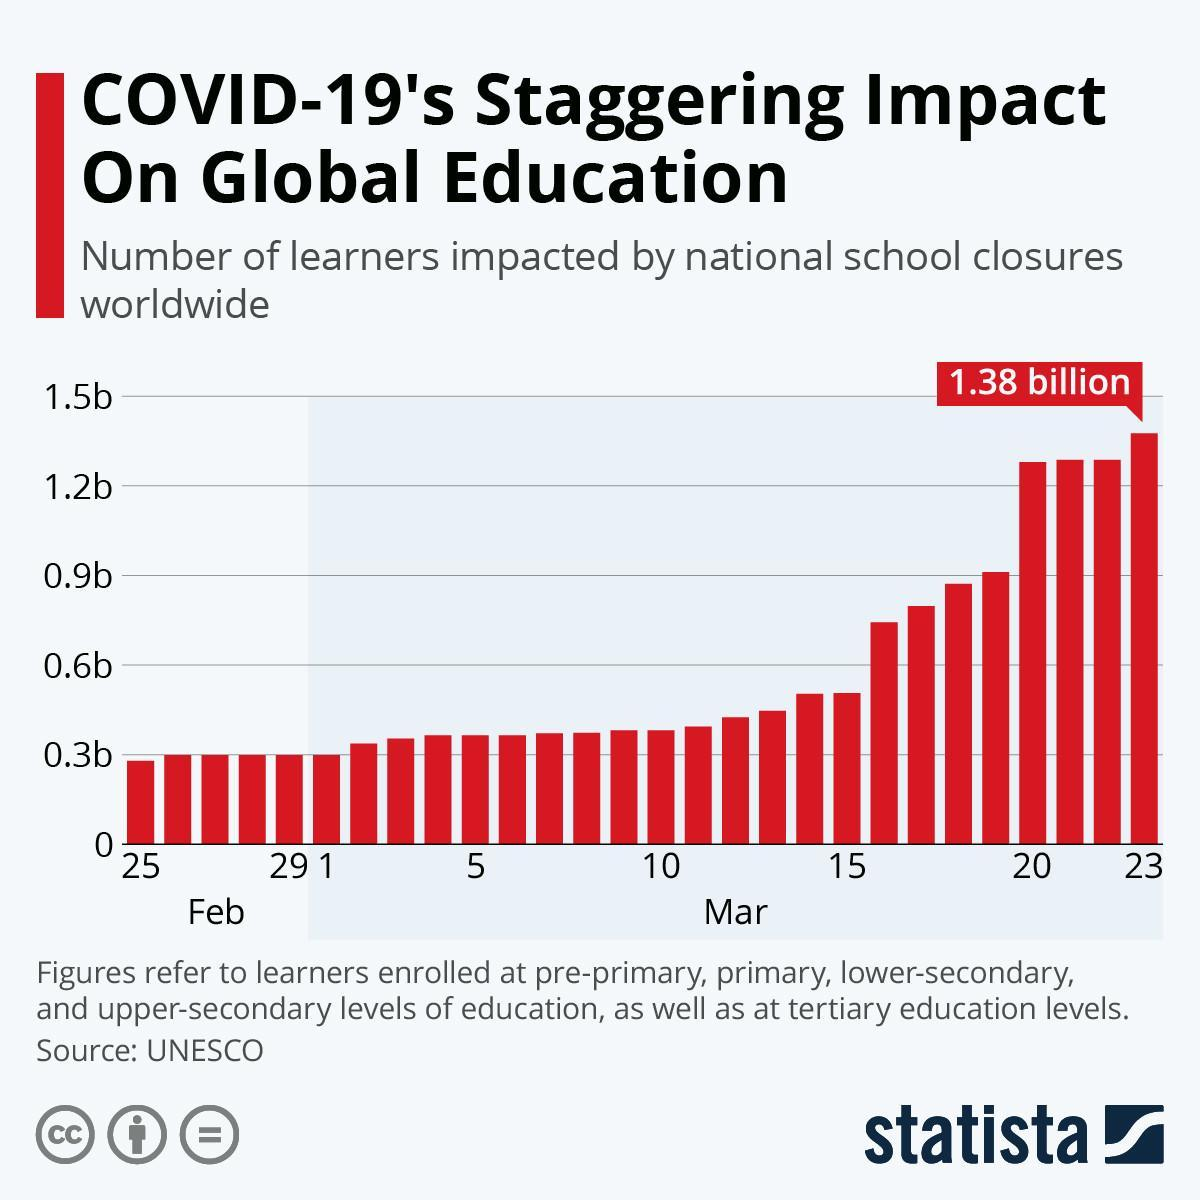WHich date and month was the impacted leaners less than 0.3b
Answer the question with a short phrase. 25, Feb From which date and which month has more than 1.2b learners been impacted due to school closure 20, Mar 